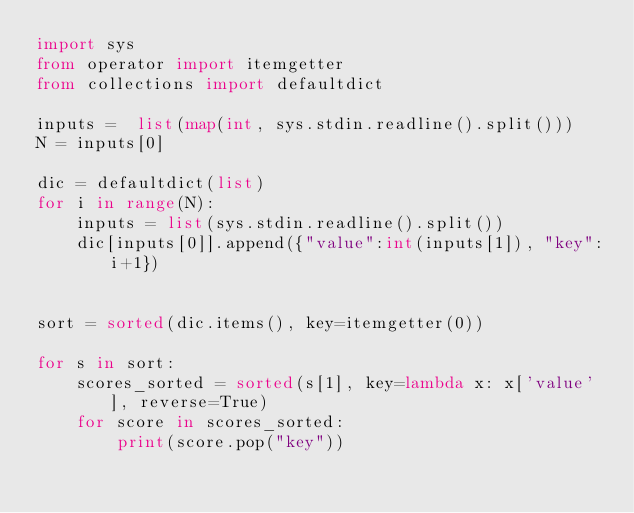<code> <loc_0><loc_0><loc_500><loc_500><_Python_>import sys
from operator import itemgetter
from collections import defaultdict

inputs =  list(map(int, sys.stdin.readline().split()))
N = inputs[0]

dic = defaultdict(list)
for i in range(N):
    inputs = list(sys.stdin.readline().split())
    dic[inputs[0]].append({"value":int(inputs[1]), "key":i+1})


sort = sorted(dic.items(), key=itemgetter(0))

for s in sort:
    scores_sorted = sorted(s[1], key=lambda x: x['value'], reverse=True)
    for score in scores_sorted:
        print(score.pop("key"))</code> 